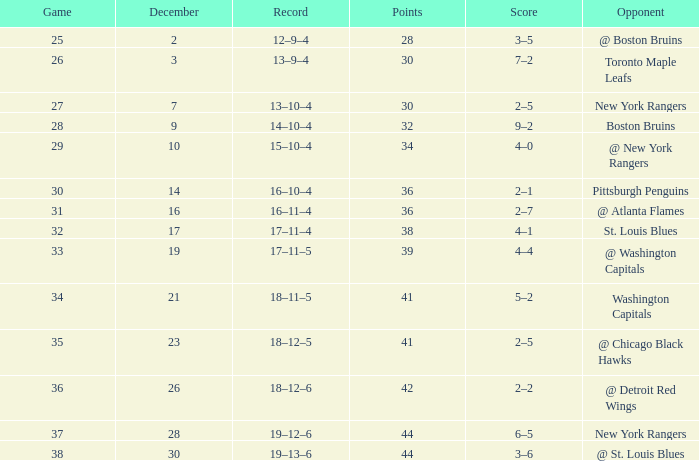Which Score has a Game larger than 32, and Points smaller than 42, and a December larger than 19, and a Record of 18–12–5? 2–5. 